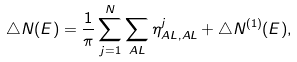<formula> <loc_0><loc_0><loc_500><loc_500>\triangle N ( E ) = \frac { 1 } { \pi } \sum _ { j = 1 } ^ { N } \sum _ { A L } \eta ^ { j } _ { A L , A L } + \triangle N ^ { ( 1 ) } ( E ) ,</formula> 